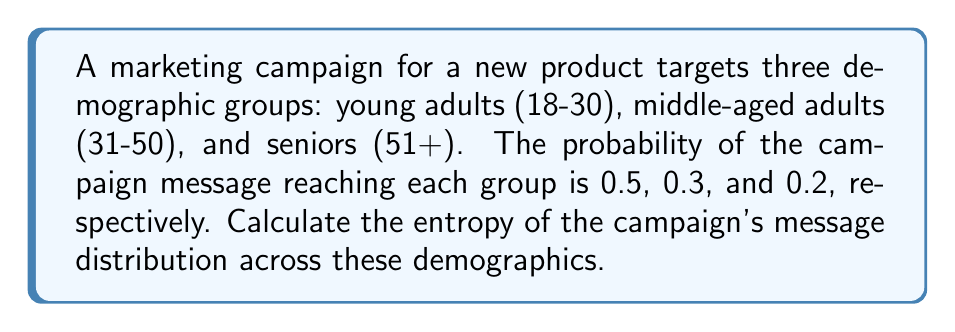Give your solution to this math problem. To calculate the entropy of the marketing campaign's message distribution, we'll use the Shannon entropy formula:

$$H = -\sum_{i=1}^{n} p_i \log_2(p_i)$$

Where:
- $H$ is the entropy
- $p_i$ is the probability of the message reaching demographic group $i$
- $n$ is the number of demographic groups

Step 1: Identify the probabilities for each demographic group
- $p_1 = 0.5$ (young adults)
- $p_2 = 0.3$ (middle-aged adults)
- $p_3 = 0.2$ (seniors)

Step 2: Calculate each term in the summation
- For young adults: $-0.5 \log_2(0.5) = 0.5$
- For middle-aged adults: $-0.3 \log_2(0.3) \approx 0.521$
- For seniors: $-0.2 \log_2(0.2) \approx 0.464$

Step 3: Sum up all terms
$$H = 0.5 + 0.521 + 0.464 = 1.485$$

Therefore, the entropy of the marketing campaign's message distribution is approximately 1.485 bits.
Answer: 1.485 bits 